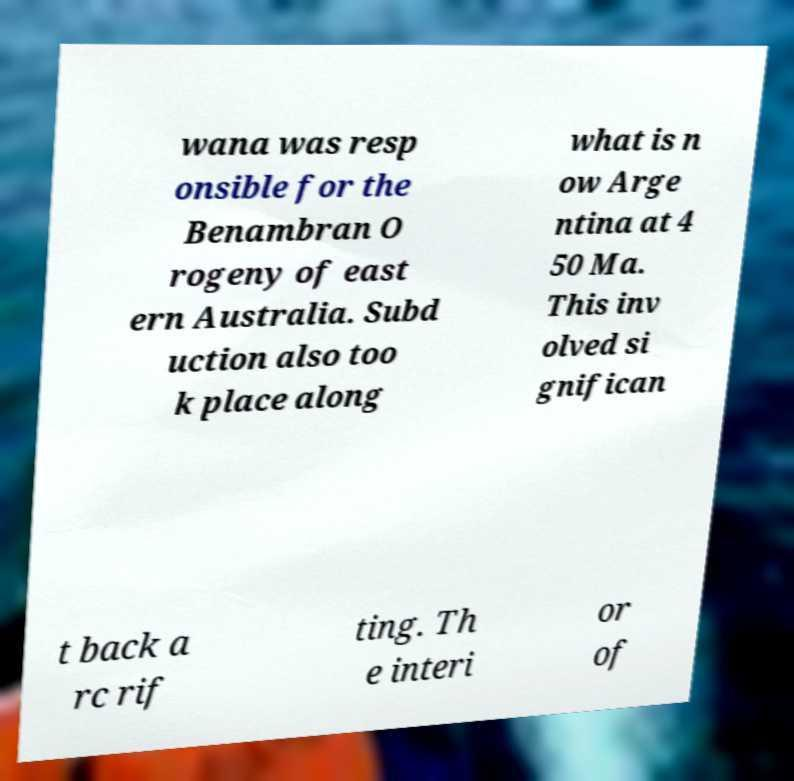Please identify and transcribe the text found in this image. wana was resp onsible for the Benambran O rogeny of east ern Australia. Subd uction also too k place along what is n ow Arge ntina at 4 50 Ma. This inv olved si gnifican t back a rc rif ting. Th e interi or of 